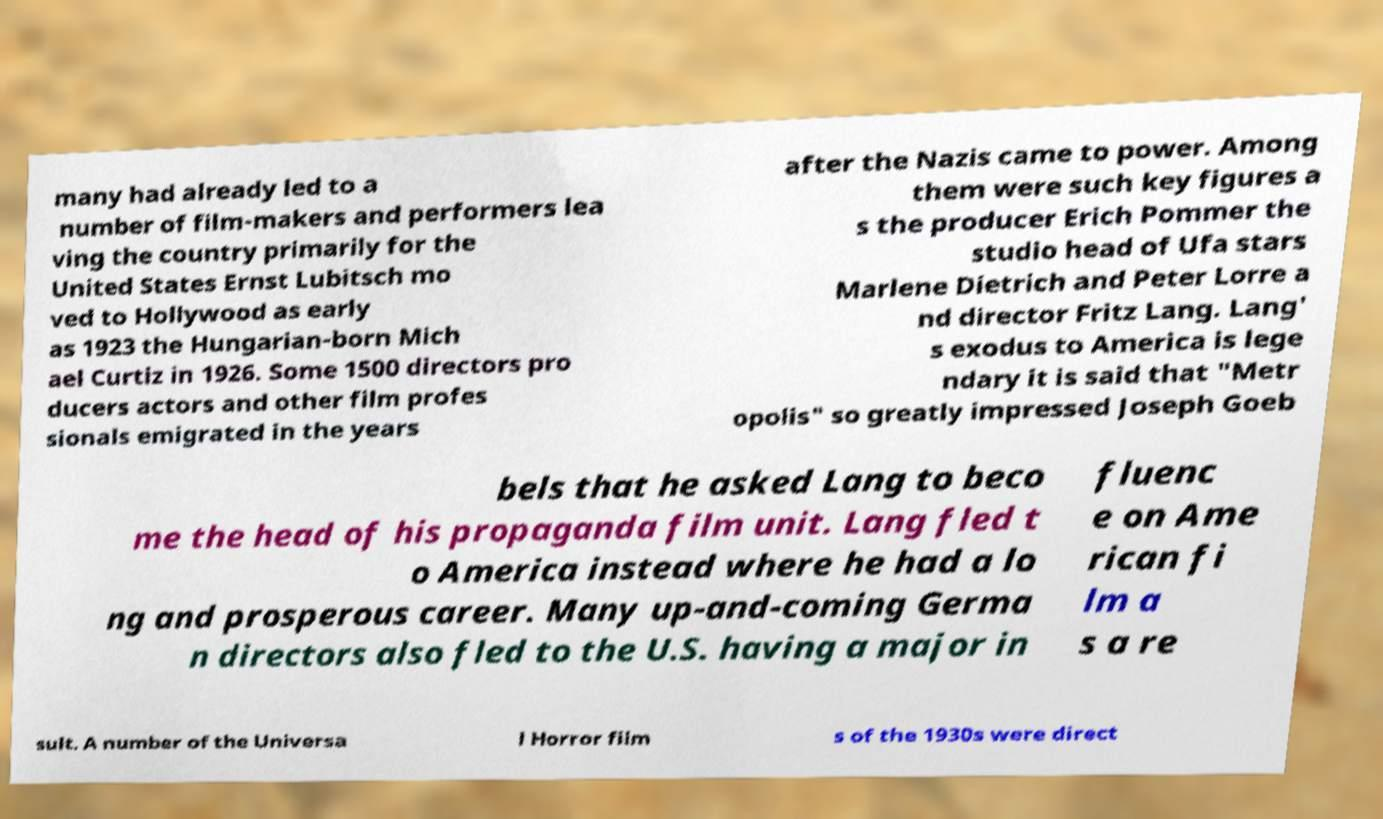There's text embedded in this image that I need extracted. Can you transcribe it verbatim? many had already led to a number of film-makers and performers lea ving the country primarily for the United States Ernst Lubitsch mo ved to Hollywood as early as 1923 the Hungarian-born Mich ael Curtiz in 1926. Some 1500 directors pro ducers actors and other film profes sionals emigrated in the years after the Nazis came to power. Among them were such key figures a s the producer Erich Pommer the studio head of Ufa stars Marlene Dietrich and Peter Lorre a nd director Fritz Lang. Lang' s exodus to America is lege ndary it is said that "Metr opolis" so greatly impressed Joseph Goeb bels that he asked Lang to beco me the head of his propaganda film unit. Lang fled t o America instead where he had a lo ng and prosperous career. Many up-and-coming Germa n directors also fled to the U.S. having a major in fluenc e on Ame rican fi lm a s a re sult. A number of the Universa l Horror film s of the 1930s were direct 